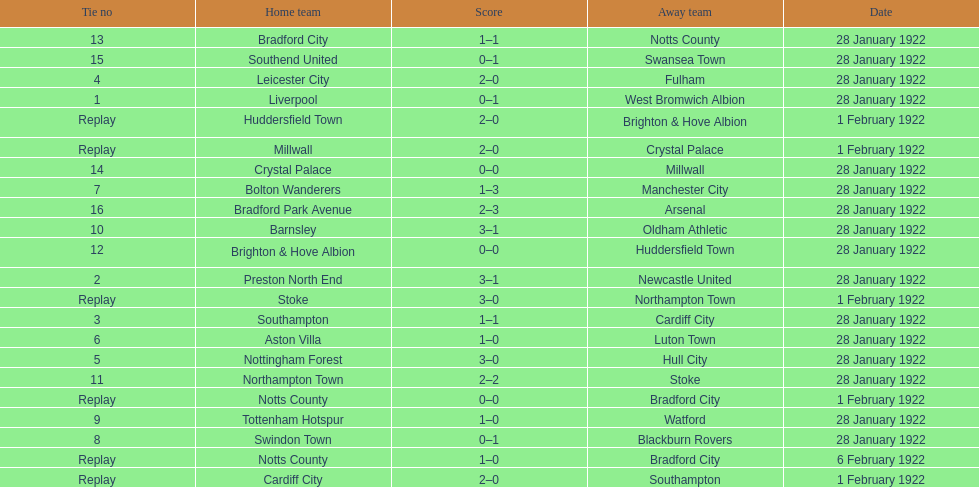How many total points were scored in the second round proper? 45. 